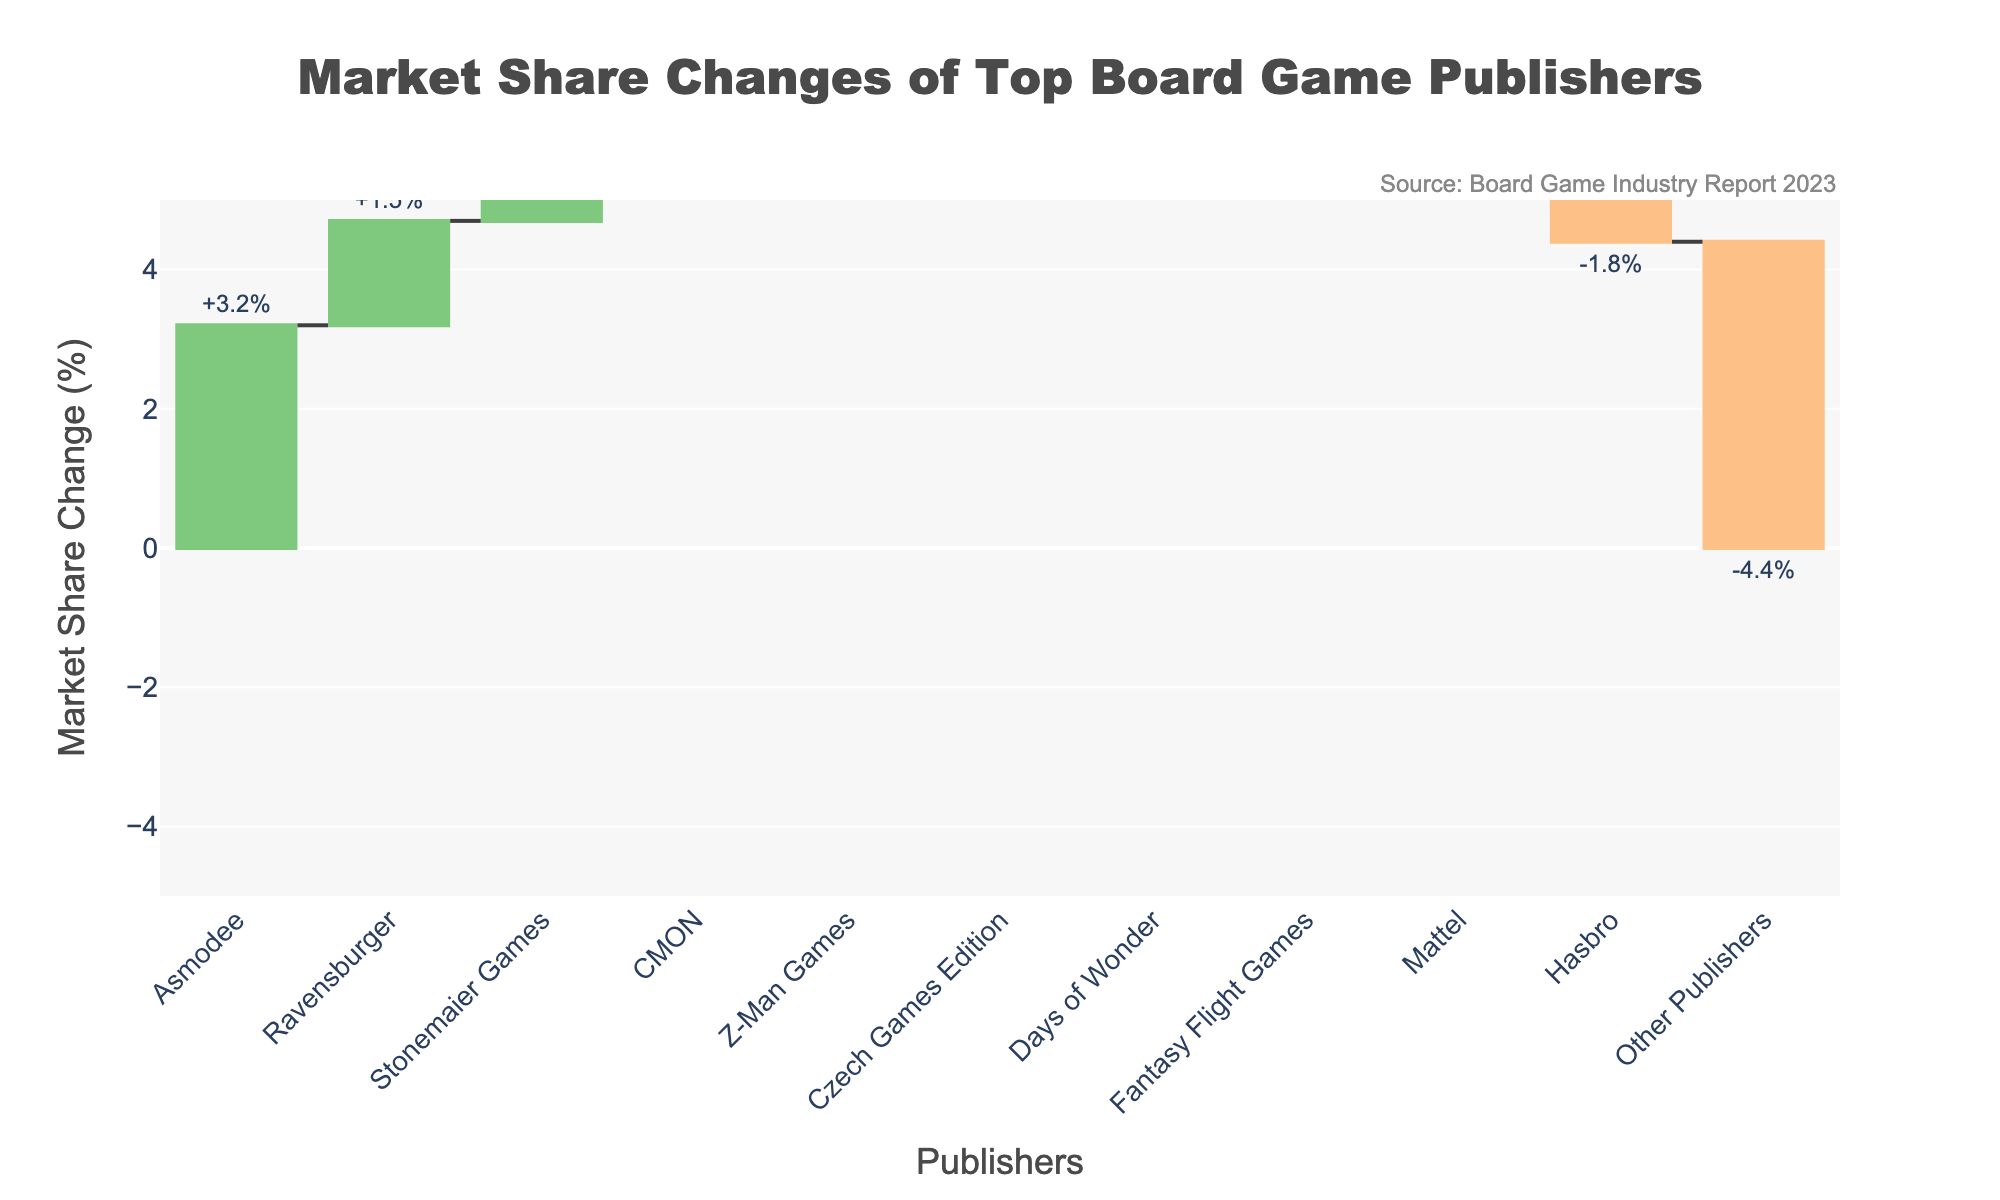Which publisher had the highest increase in market share? The waterfall chart shows the market share changes for various publishers. The highest increase is represented by the tallest green bar on the positive side.
Answer: Asmodee Which publisher saw the most significant decrease in market share? The publisher with the most significant decrease is represented by the largest red bar on the negative side.
Answer: Other Publishers What is the total market share change for Asmodee and Ravensburger combined? To find the total market share change, add the changes for both publishers. Asmodee: +3.2%, Ravensburger: +1.5%. Sum: 3.2% + 1.5% = 4.7%
Answer: 4.7% How many publishers experienced a decrease in market share? Count the number of red bars representing negative changes. There are 4 such bars.
Answer: 4 Is Hasbro's market share change greater than Fantasy Flight Games' market share change? Compare the values for Hasbro and Fantasy Flight Games. Hasbro: -1.8%, Fantasy Flight Games: -0.5%. Hasbro's negative change is greater.
Answer: Yes What is the overall trend in market share changes for all publishers combined? To determine the overall trend, sum all individual changes. (3.2 - 1.8 + 1.5 - 0.7 + 0.9 - 0.3 + 0.6 - 0.5 + 1.1 + 0.4 - 4.4)%. Sum: 0%
Answer: 0% What is the range of market share changes shown in the chart? The range is calculated by subtracting the smallest value from the largest value. Largest: +3.2%, Smallest: -4.4%. Range: 3.2% - (-4.4%) = 7.6%
Answer: 7.6% How many publishers had a market share change of over 1%? Count the number of bars whose values are greater than 1% (either positive or negative). There are 3 such bars: Asmodee, Hasbro, and Ravensburger.
Answer: 3 Did Stonemaier Games experience an increase or decrease in market share? Look at the color and position of Stonemaier Games' bar. It is green and above zero, indicating an increase.
Answer: Increase Which publisher had a smaller market share decrease: Mattel or Days of Wonder? Compare the values for Mattel and Days of Wonder. Mattel: -0.7%, Days of Wonder: -0.3%. Days of Wonder's decrease is smaller.
Answer: Days of Wonder 